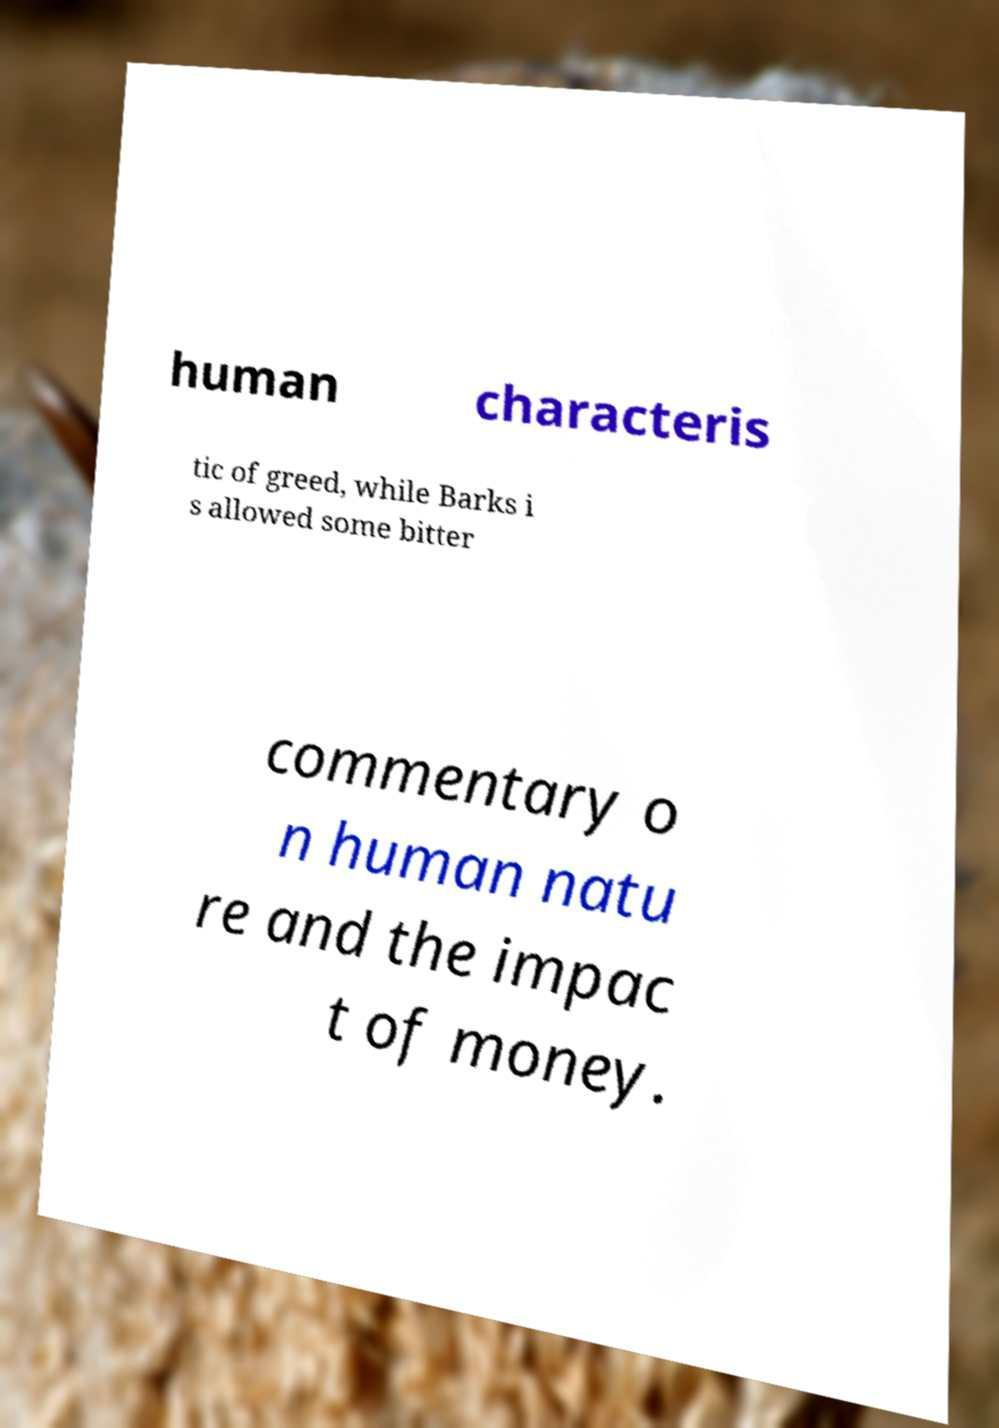For documentation purposes, I need the text within this image transcribed. Could you provide that? human characteris tic of greed, while Barks i s allowed some bitter commentary o n human natu re and the impac t of money. 